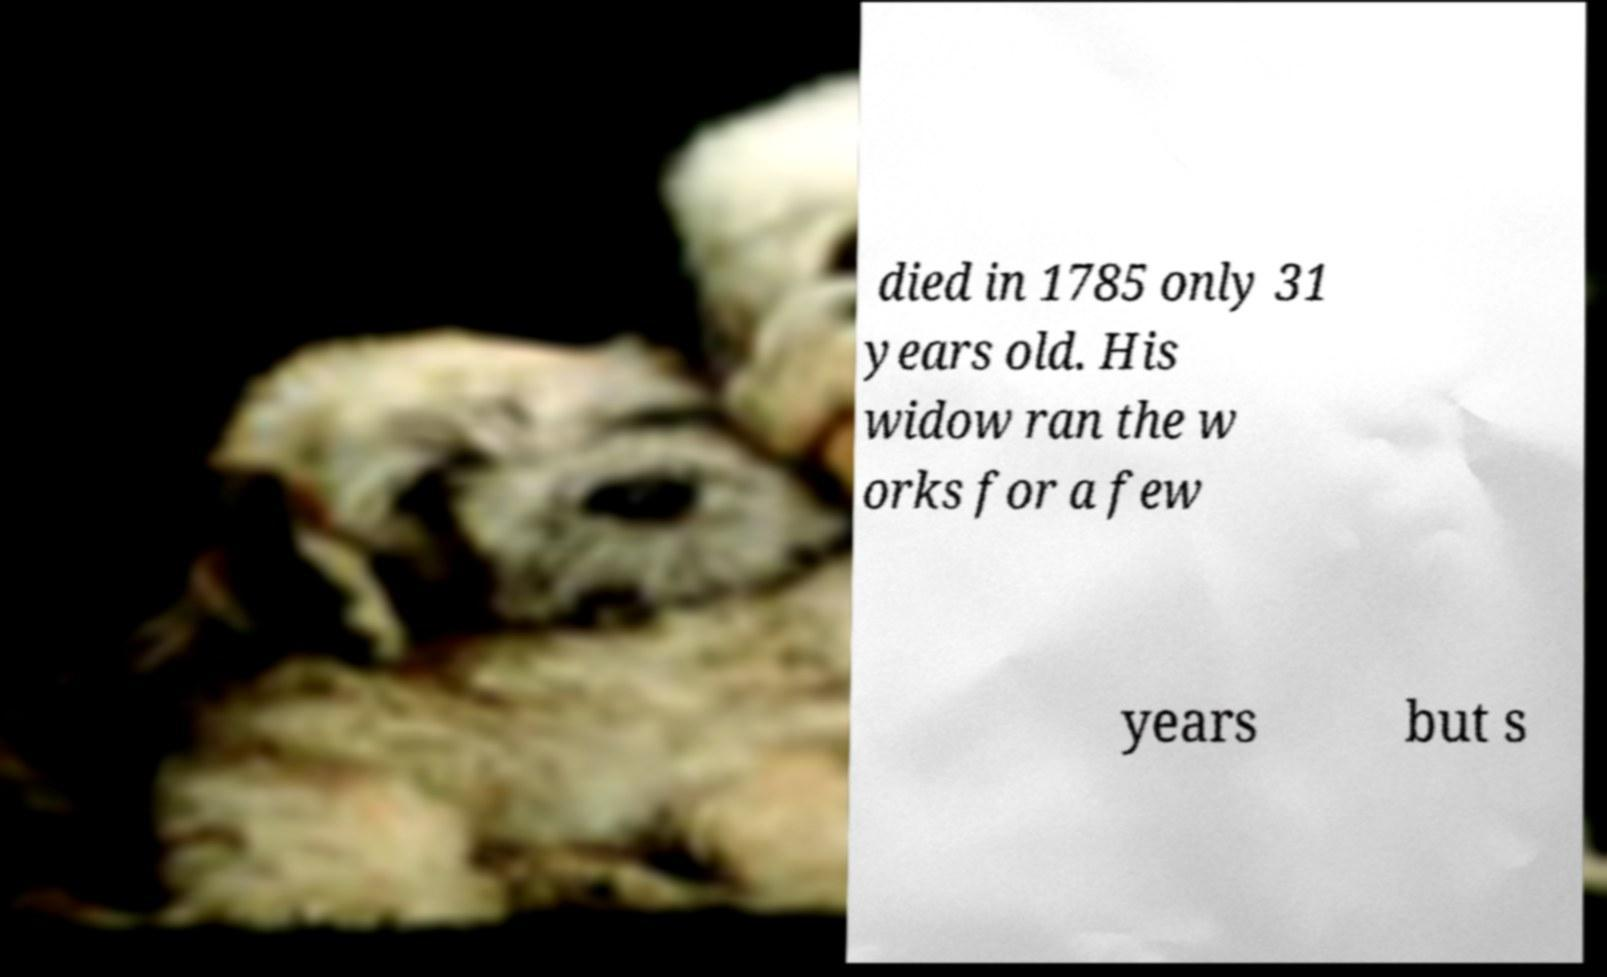Can you accurately transcribe the text from the provided image for me? died in 1785 only 31 years old. His widow ran the w orks for a few years but s 